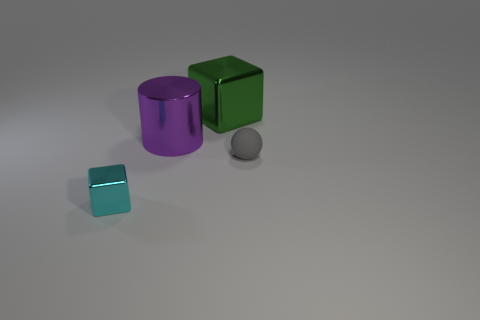Is there any other thing that has the same material as the small ball?
Provide a succinct answer. No. Are there any cyan cubes made of the same material as the purple object?
Offer a very short reply. Yes. There is a cube on the left side of the block that is right of the metal block left of the purple thing; what color is it?
Offer a very short reply. Cyan. How many yellow things are metallic blocks or large metallic cylinders?
Provide a succinct answer. 0. What number of other green objects are the same shape as the big green metal thing?
Your response must be concise. 0. There is a gray rubber object that is the same size as the cyan cube; what is its shape?
Provide a succinct answer. Sphere. Are there any cylinders right of the large green metal cube?
Give a very brief answer. No. Are there any small cyan blocks to the right of the tiny object that is to the right of the large block?
Offer a terse response. No. Are there fewer big purple cylinders that are on the right side of the cyan shiny cube than purple shiny cylinders that are in front of the matte thing?
Keep it short and to the point. No. What shape is the cyan thing?
Offer a very short reply. Cube. 